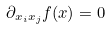<formula> <loc_0><loc_0><loc_500><loc_500>\partial _ { x _ { i } x _ { j } } f ( x ) = 0</formula> 